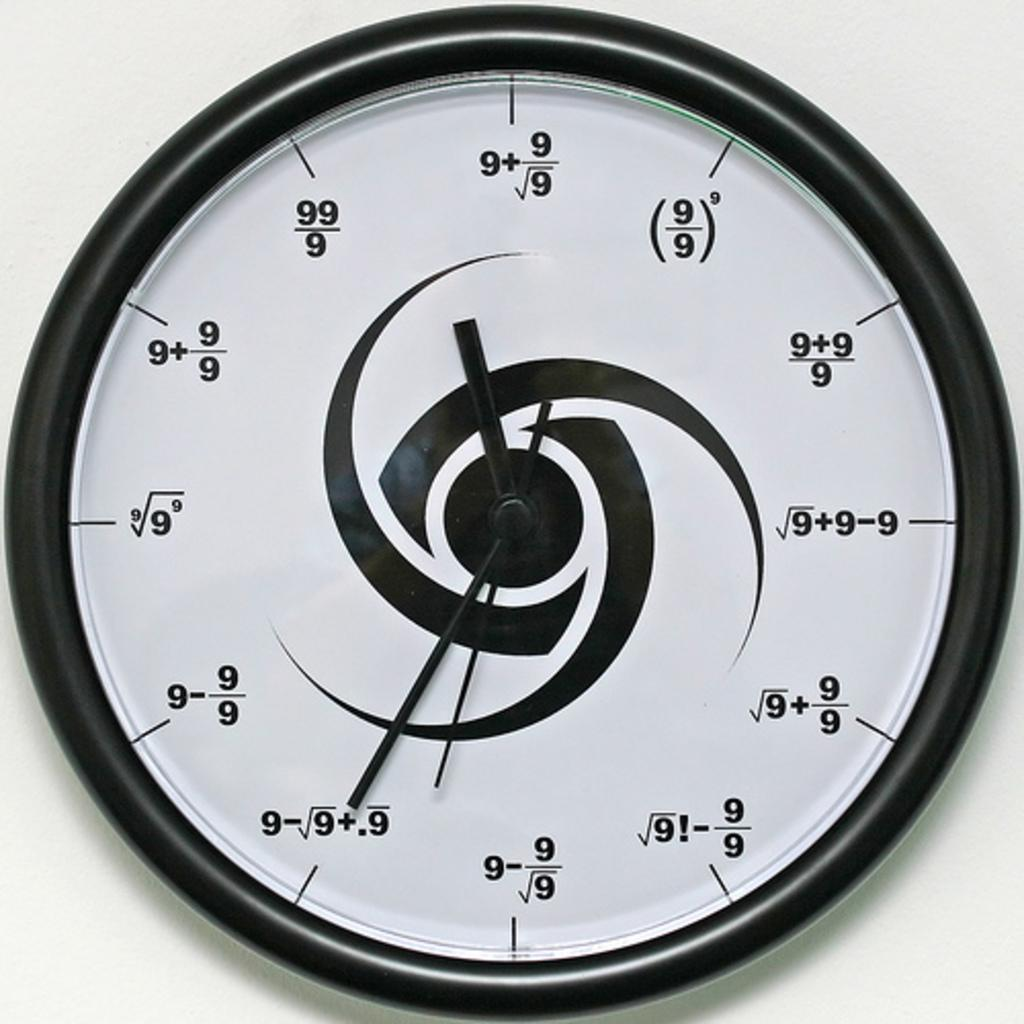Provide a one-sentence caption for the provided image. A clock displays numbers in various mathematical formulas using only the number 9 many times. 